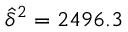<formula> <loc_0><loc_0><loc_500><loc_500>\widehat { \delta } ^ { 2 } = 2 4 9 6 . 3</formula> 